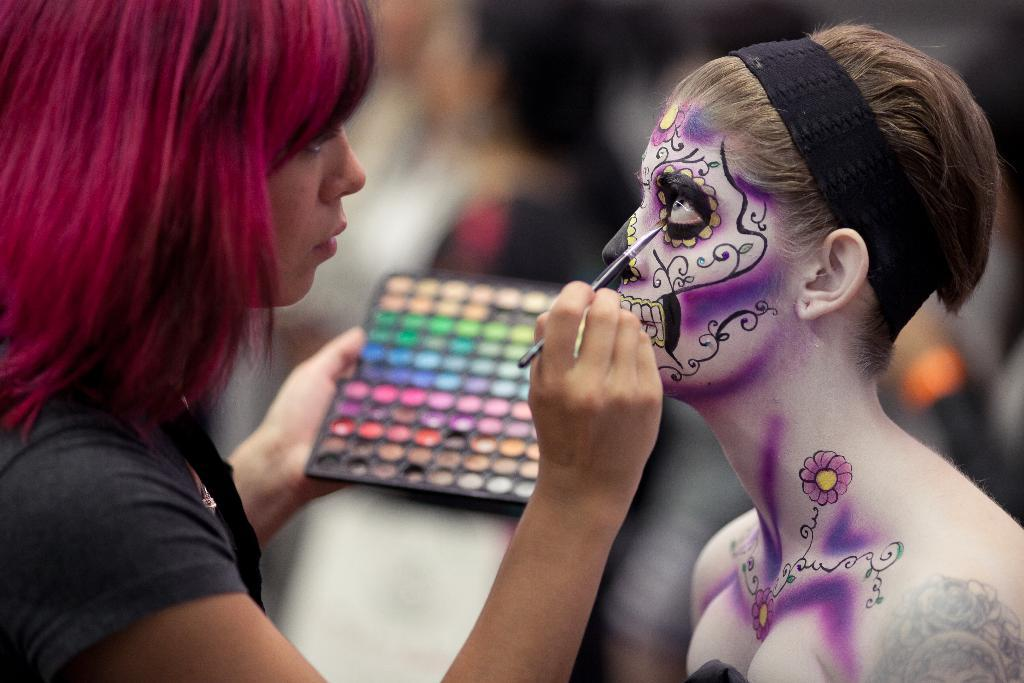How many women are present in the image? There are two women in the image. Can you describe what the woman on the left side is doing? The woman on the left side is holding objects in her hands. What is unique about the appearance of the woman on the right side? The woman on the right side is wearing a black object on her head. How many kittens can be seen playing in the stream in the image? There are no kittens or streams present in the image. Is the woman on the right side participating in a flight in the image? There is no indication of a flight or any related activity in the image. 